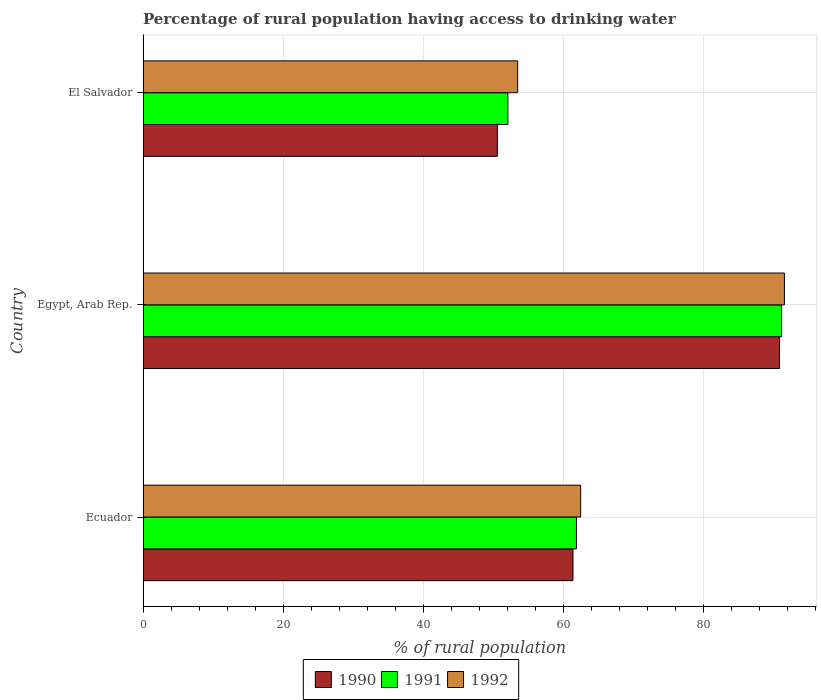How many different coloured bars are there?
Ensure brevity in your answer.  3. What is the label of the 1st group of bars from the top?
Your answer should be very brief. El Salvador. What is the percentage of rural population having access to drinking water in 1991 in Egypt, Arab Rep.?
Provide a short and direct response. 91.2. Across all countries, what is the maximum percentage of rural population having access to drinking water in 1990?
Provide a short and direct response. 90.9. Across all countries, what is the minimum percentage of rural population having access to drinking water in 1991?
Give a very brief answer. 52.1. In which country was the percentage of rural population having access to drinking water in 1992 maximum?
Your response must be concise. Egypt, Arab Rep. In which country was the percentage of rural population having access to drinking water in 1991 minimum?
Your answer should be compact. El Salvador. What is the total percentage of rural population having access to drinking water in 1992 in the graph?
Provide a short and direct response. 207.6. What is the difference between the percentage of rural population having access to drinking water in 1991 in Ecuador and that in El Salvador?
Provide a short and direct response. 9.8. What is the difference between the percentage of rural population having access to drinking water in 1992 in Egypt, Arab Rep. and the percentage of rural population having access to drinking water in 1990 in Ecuador?
Keep it short and to the point. 30.2. What is the average percentage of rural population having access to drinking water in 1991 per country?
Your answer should be compact. 68.4. What is the difference between the percentage of rural population having access to drinking water in 1992 and percentage of rural population having access to drinking water in 1991 in El Salvador?
Give a very brief answer. 1.4. In how many countries, is the percentage of rural population having access to drinking water in 1992 greater than 8 %?
Offer a very short reply. 3. What is the ratio of the percentage of rural population having access to drinking water in 1990 in Egypt, Arab Rep. to that in El Salvador?
Offer a terse response. 1.8. Is the percentage of rural population having access to drinking water in 1990 in Ecuador less than that in El Salvador?
Your answer should be compact. No. Is the difference between the percentage of rural population having access to drinking water in 1992 in Egypt, Arab Rep. and El Salvador greater than the difference between the percentage of rural population having access to drinking water in 1991 in Egypt, Arab Rep. and El Salvador?
Your response must be concise. No. What is the difference between the highest and the second highest percentage of rural population having access to drinking water in 1991?
Ensure brevity in your answer.  29.3. What is the difference between the highest and the lowest percentage of rural population having access to drinking water in 1991?
Keep it short and to the point. 39.1. In how many countries, is the percentage of rural population having access to drinking water in 1990 greater than the average percentage of rural population having access to drinking water in 1990 taken over all countries?
Your response must be concise. 1. What does the 3rd bar from the bottom in Egypt, Arab Rep. represents?
Keep it short and to the point. 1992. Are the values on the major ticks of X-axis written in scientific E-notation?
Your response must be concise. No. How many legend labels are there?
Ensure brevity in your answer.  3. What is the title of the graph?
Make the answer very short. Percentage of rural population having access to drinking water. What is the label or title of the X-axis?
Offer a terse response. % of rural population. What is the label or title of the Y-axis?
Your answer should be compact. Country. What is the % of rural population of 1990 in Ecuador?
Keep it short and to the point. 61.4. What is the % of rural population of 1991 in Ecuador?
Ensure brevity in your answer.  61.9. What is the % of rural population in 1992 in Ecuador?
Your response must be concise. 62.5. What is the % of rural population of 1990 in Egypt, Arab Rep.?
Your answer should be very brief. 90.9. What is the % of rural population in 1991 in Egypt, Arab Rep.?
Provide a succinct answer. 91.2. What is the % of rural population of 1992 in Egypt, Arab Rep.?
Offer a very short reply. 91.6. What is the % of rural population of 1990 in El Salvador?
Provide a short and direct response. 50.6. What is the % of rural population of 1991 in El Salvador?
Give a very brief answer. 52.1. What is the % of rural population in 1992 in El Salvador?
Your answer should be compact. 53.5. Across all countries, what is the maximum % of rural population of 1990?
Your response must be concise. 90.9. Across all countries, what is the maximum % of rural population of 1991?
Give a very brief answer. 91.2. Across all countries, what is the maximum % of rural population in 1992?
Give a very brief answer. 91.6. Across all countries, what is the minimum % of rural population in 1990?
Your answer should be compact. 50.6. Across all countries, what is the minimum % of rural population of 1991?
Make the answer very short. 52.1. Across all countries, what is the minimum % of rural population in 1992?
Offer a terse response. 53.5. What is the total % of rural population of 1990 in the graph?
Make the answer very short. 202.9. What is the total % of rural population in 1991 in the graph?
Offer a terse response. 205.2. What is the total % of rural population of 1992 in the graph?
Make the answer very short. 207.6. What is the difference between the % of rural population in 1990 in Ecuador and that in Egypt, Arab Rep.?
Your answer should be compact. -29.5. What is the difference between the % of rural population in 1991 in Ecuador and that in Egypt, Arab Rep.?
Your response must be concise. -29.3. What is the difference between the % of rural population of 1992 in Ecuador and that in Egypt, Arab Rep.?
Ensure brevity in your answer.  -29.1. What is the difference between the % of rural population in 1992 in Ecuador and that in El Salvador?
Offer a very short reply. 9. What is the difference between the % of rural population in 1990 in Egypt, Arab Rep. and that in El Salvador?
Keep it short and to the point. 40.3. What is the difference between the % of rural population in 1991 in Egypt, Arab Rep. and that in El Salvador?
Give a very brief answer. 39.1. What is the difference between the % of rural population in 1992 in Egypt, Arab Rep. and that in El Salvador?
Offer a terse response. 38.1. What is the difference between the % of rural population of 1990 in Ecuador and the % of rural population of 1991 in Egypt, Arab Rep.?
Offer a terse response. -29.8. What is the difference between the % of rural population in 1990 in Ecuador and the % of rural population in 1992 in Egypt, Arab Rep.?
Ensure brevity in your answer.  -30.2. What is the difference between the % of rural population in 1991 in Ecuador and the % of rural population in 1992 in Egypt, Arab Rep.?
Keep it short and to the point. -29.7. What is the difference between the % of rural population in 1990 in Ecuador and the % of rural population in 1991 in El Salvador?
Provide a short and direct response. 9.3. What is the difference between the % of rural population in 1991 in Ecuador and the % of rural population in 1992 in El Salvador?
Your answer should be very brief. 8.4. What is the difference between the % of rural population of 1990 in Egypt, Arab Rep. and the % of rural population of 1991 in El Salvador?
Your answer should be very brief. 38.8. What is the difference between the % of rural population of 1990 in Egypt, Arab Rep. and the % of rural population of 1992 in El Salvador?
Give a very brief answer. 37.4. What is the difference between the % of rural population in 1991 in Egypt, Arab Rep. and the % of rural population in 1992 in El Salvador?
Give a very brief answer. 37.7. What is the average % of rural population in 1990 per country?
Give a very brief answer. 67.63. What is the average % of rural population in 1991 per country?
Your answer should be compact. 68.4. What is the average % of rural population in 1992 per country?
Your response must be concise. 69.2. What is the difference between the % of rural population of 1990 and % of rural population of 1991 in Ecuador?
Your response must be concise. -0.5. What is the difference between the % of rural population of 1990 and % of rural population of 1992 in Ecuador?
Keep it short and to the point. -1.1. What is the difference between the % of rural population of 1990 and % of rural population of 1992 in Egypt, Arab Rep.?
Offer a very short reply. -0.7. What is the difference between the % of rural population in 1991 and % of rural population in 1992 in Egypt, Arab Rep.?
Keep it short and to the point. -0.4. What is the difference between the % of rural population in 1990 and % of rural population in 1991 in El Salvador?
Keep it short and to the point. -1.5. What is the difference between the % of rural population of 1990 and % of rural population of 1992 in El Salvador?
Provide a succinct answer. -2.9. What is the ratio of the % of rural population of 1990 in Ecuador to that in Egypt, Arab Rep.?
Keep it short and to the point. 0.68. What is the ratio of the % of rural population in 1991 in Ecuador to that in Egypt, Arab Rep.?
Your answer should be compact. 0.68. What is the ratio of the % of rural population of 1992 in Ecuador to that in Egypt, Arab Rep.?
Make the answer very short. 0.68. What is the ratio of the % of rural population in 1990 in Ecuador to that in El Salvador?
Your answer should be compact. 1.21. What is the ratio of the % of rural population of 1991 in Ecuador to that in El Salvador?
Ensure brevity in your answer.  1.19. What is the ratio of the % of rural population in 1992 in Ecuador to that in El Salvador?
Keep it short and to the point. 1.17. What is the ratio of the % of rural population in 1990 in Egypt, Arab Rep. to that in El Salvador?
Your response must be concise. 1.8. What is the ratio of the % of rural population in 1991 in Egypt, Arab Rep. to that in El Salvador?
Keep it short and to the point. 1.75. What is the ratio of the % of rural population in 1992 in Egypt, Arab Rep. to that in El Salvador?
Keep it short and to the point. 1.71. What is the difference between the highest and the second highest % of rural population in 1990?
Ensure brevity in your answer.  29.5. What is the difference between the highest and the second highest % of rural population of 1991?
Provide a short and direct response. 29.3. What is the difference between the highest and the second highest % of rural population in 1992?
Provide a short and direct response. 29.1. What is the difference between the highest and the lowest % of rural population in 1990?
Provide a succinct answer. 40.3. What is the difference between the highest and the lowest % of rural population of 1991?
Your answer should be very brief. 39.1. What is the difference between the highest and the lowest % of rural population of 1992?
Your response must be concise. 38.1. 